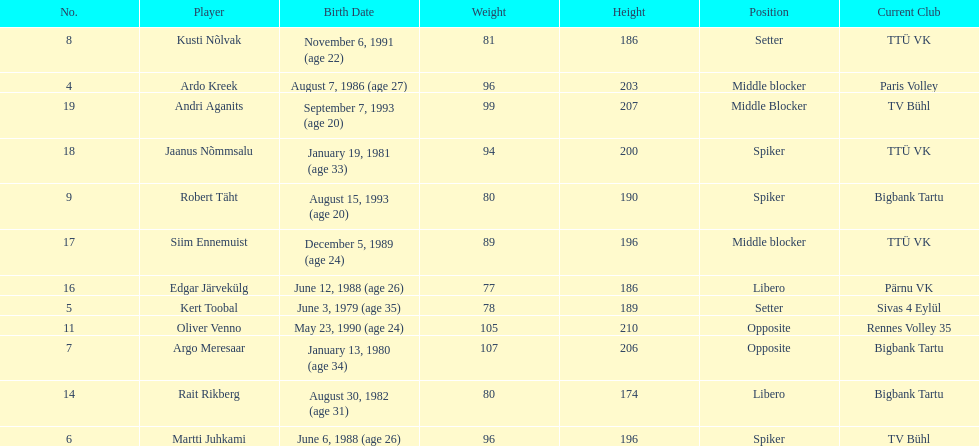Who is at least 25 years or older? Ardo Kreek, Kert Toobal, Martti Juhkami, Argo Meresaar, Rait Rikberg, Edgar Järvekülg, Jaanus Nõmmsalu. 